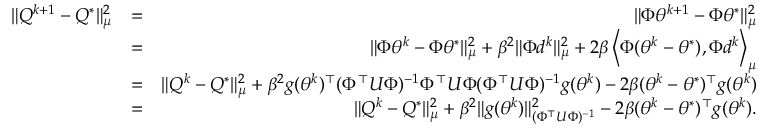Convert formula to latex. <formula><loc_0><loc_0><loc_500><loc_500>\begin{array} { r l r } { \| Q ^ { k + 1 } - Q ^ { * } \| _ { \mu } ^ { 2 } } & { = } & { \| \Phi \theta ^ { k + 1 } - \Phi \theta ^ { * } \| _ { \mu } ^ { 2 } } \\ & { = } & { \| \Phi \theta ^ { k } - \Phi \theta ^ { * } \| _ { \mu } ^ { 2 } + \beta ^ { 2 } \| \Phi d ^ { k } \| _ { \mu } ^ { 2 } + 2 \beta \left < \Phi ( \theta ^ { k } - \theta ^ { * } ) , \Phi d ^ { k } \right > _ { \mu } } \\ & { = } & { \| Q ^ { k } - Q ^ { * } \| _ { \mu } ^ { 2 } + \beta ^ { 2 } g ( \theta ^ { k } ) ^ { \top } ( \Phi ^ { \top } U \Phi ) ^ { - 1 } \Phi ^ { \top } U \Phi ( \Phi ^ { \top } U \Phi ) ^ { - 1 } g ( \theta ^ { k } ) - 2 \beta ( \theta ^ { k } - \theta ^ { * } ) ^ { \top } g ( \theta ^ { k } ) } \\ & { = } & { \| Q ^ { k } - Q ^ { * } \| _ { \mu } ^ { 2 } + \beta ^ { 2 } \| g ( \theta ^ { k } ) \| _ { ( \Phi ^ { \top } U \Phi ) ^ { - 1 } } ^ { 2 } - 2 \beta ( \theta ^ { k } - \theta ^ { * } ) ^ { \top } g ( \theta ^ { k } ) . } \end{array}</formula> 